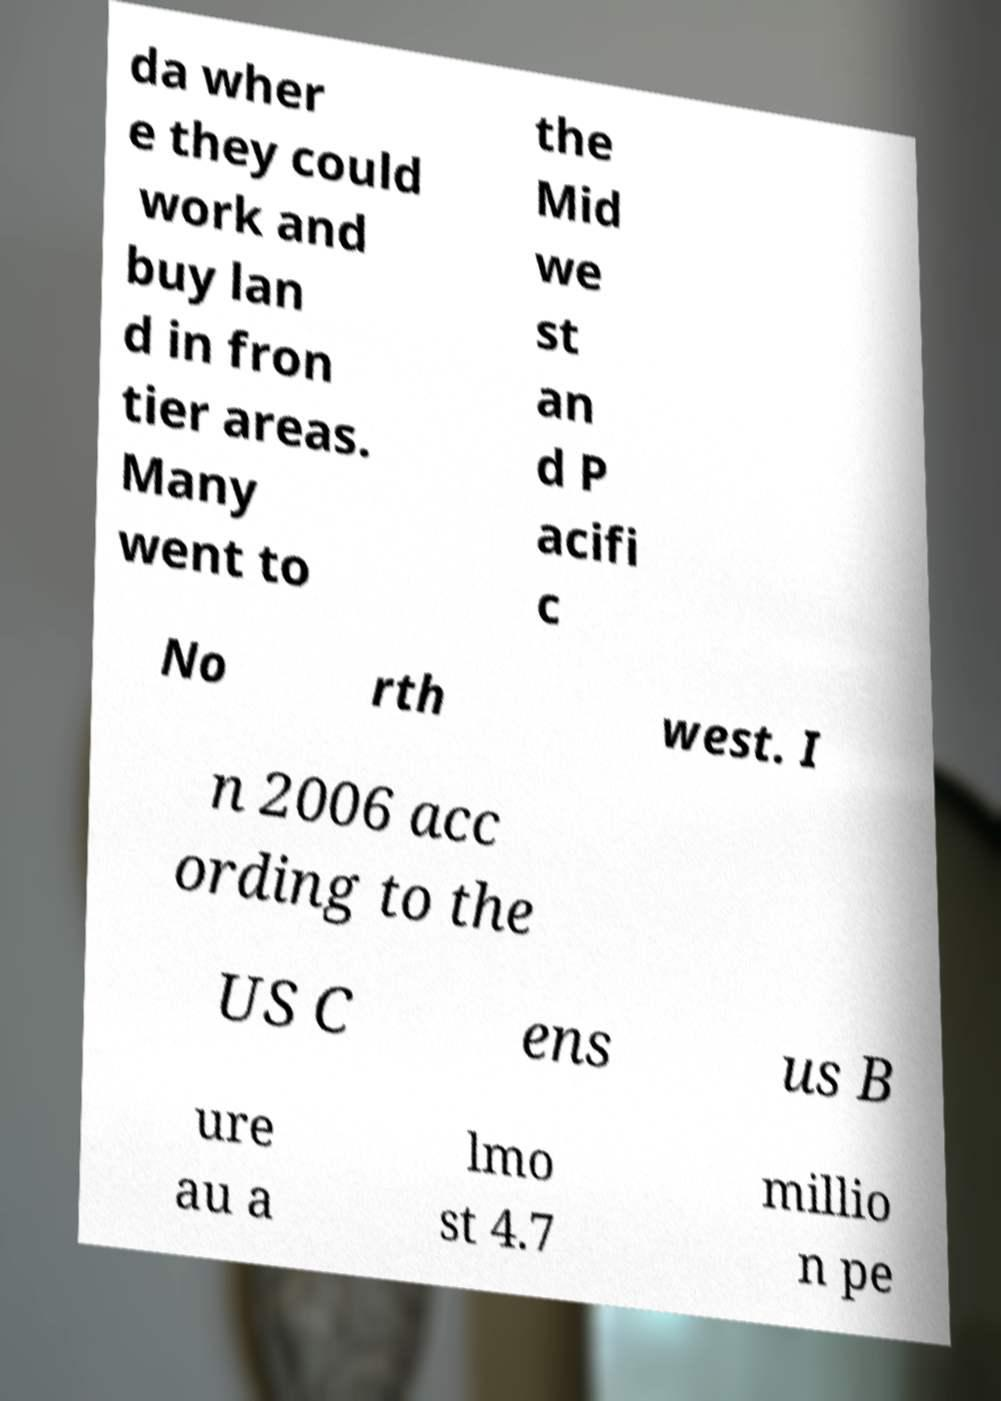Please read and relay the text visible in this image. What does it say? da wher e they could work and buy lan d in fron tier areas. Many went to the Mid we st an d P acifi c No rth west. I n 2006 acc ording to the US C ens us B ure au a lmo st 4.7 millio n pe 